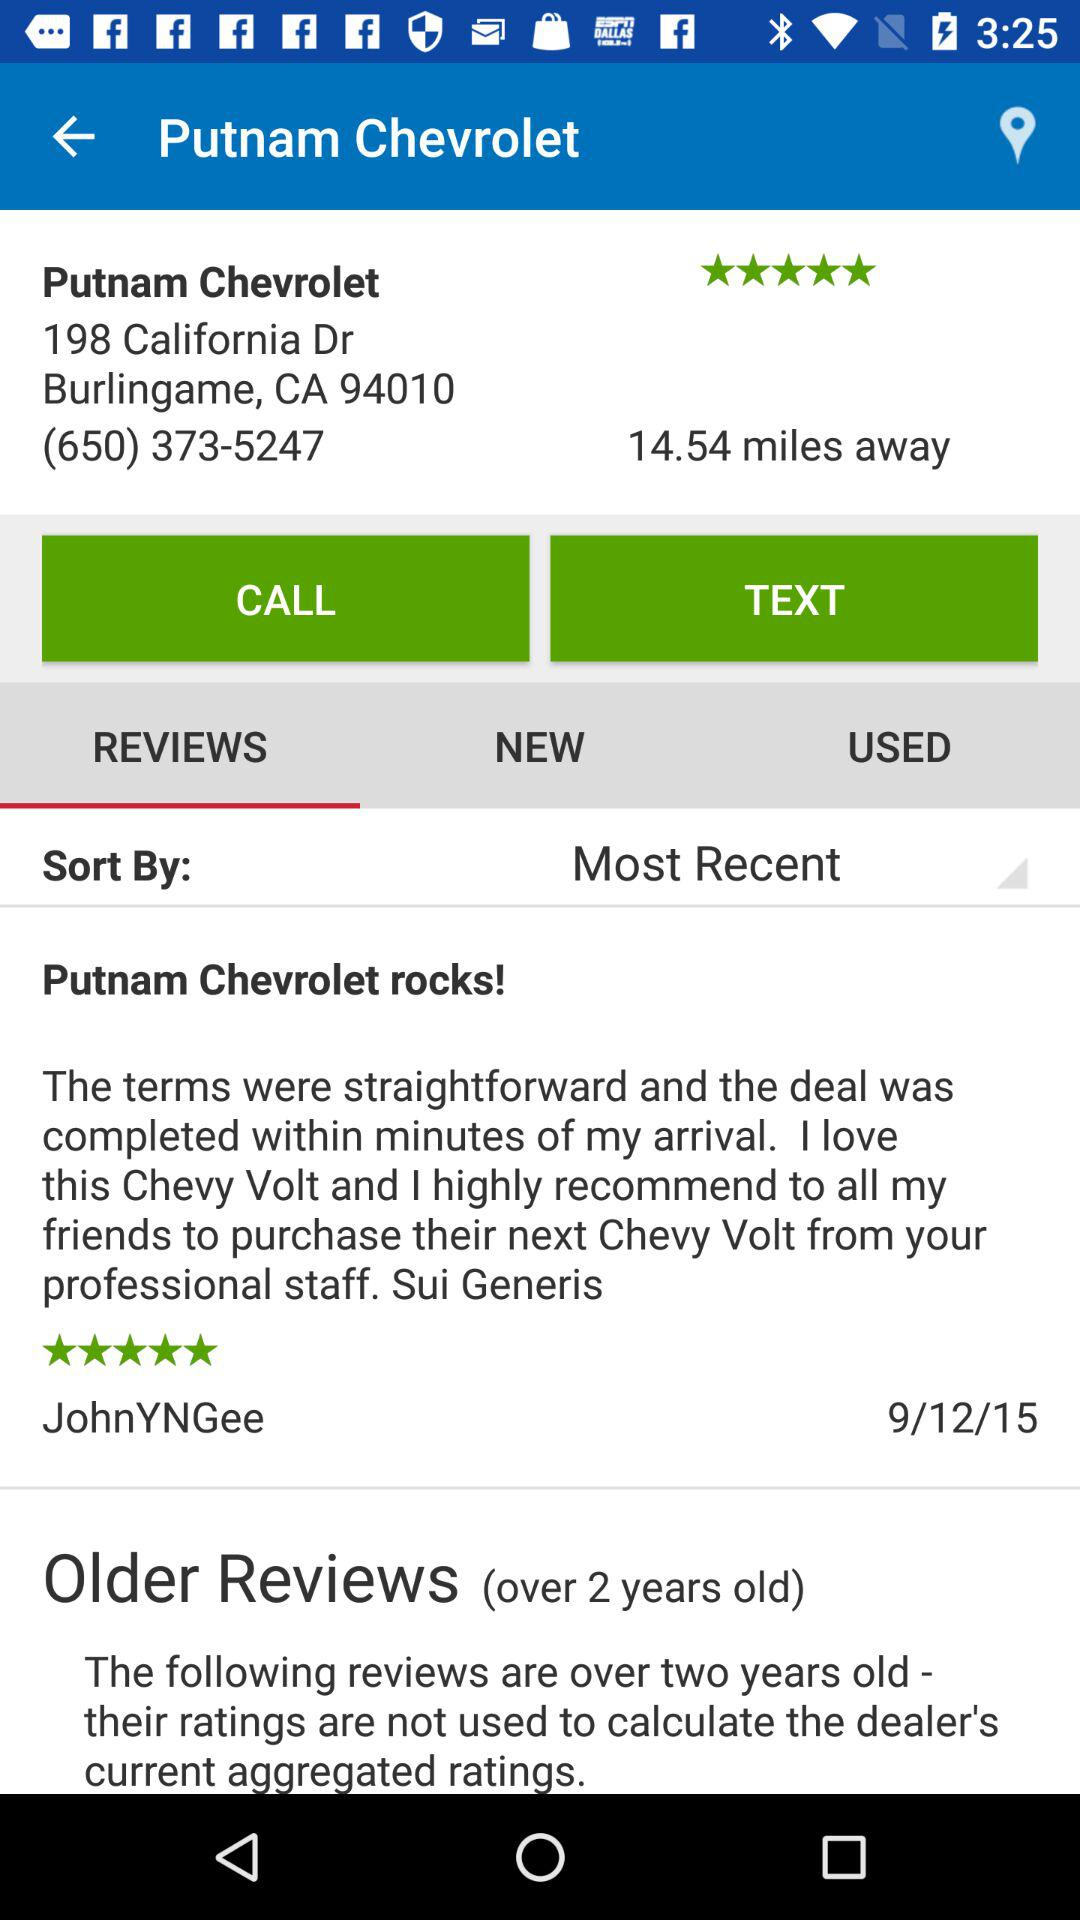What is the rating for "Putnam Chevrolet"? The rating is 5 stars. 